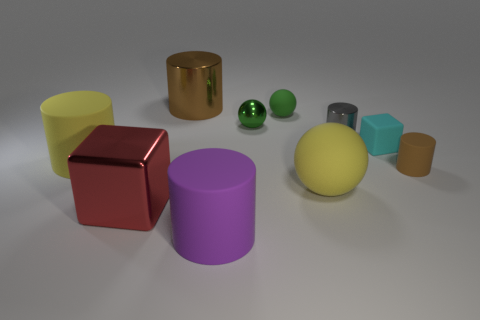The object that is the same color as the big rubber sphere is what size?
Offer a terse response. Large. What shape is the metal thing that is the same color as the small matte sphere?
Give a very brief answer. Sphere. There is a shiny cylinder in front of the tiny metal object that is behind the gray shiny object; what size is it?
Offer a very short reply. Small. Is the gray metallic cylinder the same size as the brown matte cylinder?
Make the answer very short. Yes. There is a rubber cylinder in front of the large yellow matte thing that is in front of the brown matte object; are there any small brown matte things that are to the left of it?
Offer a very short reply. No. How big is the purple cylinder?
Your answer should be very brief. Large. How many green matte things are the same size as the cyan thing?
Offer a very short reply. 1. There is another tiny thing that is the same shape as the red shiny thing; what is its material?
Ensure brevity in your answer.  Rubber. There is a big rubber thing that is both to the right of the big brown thing and behind the big red block; what shape is it?
Provide a short and direct response. Sphere. What shape is the yellow object right of the big shiny cylinder?
Provide a succinct answer. Sphere. 